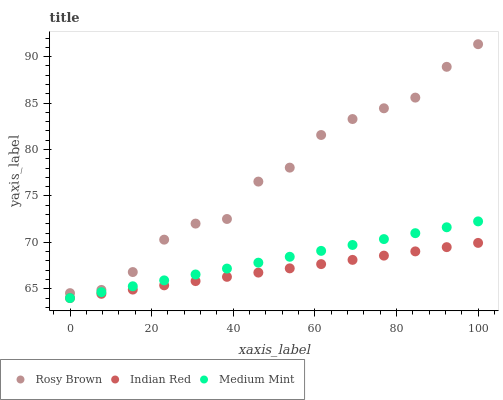Does Indian Red have the minimum area under the curve?
Answer yes or no. Yes. Does Rosy Brown have the maximum area under the curve?
Answer yes or no. Yes. Does Rosy Brown have the minimum area under the curve?
Answer yes or no. No. Does Indian Red have the maximum area under the curve?
Answer yes or no. No. Is Medium Mint the smoothest?
Answer yes or no. Yes. Is Rosy Brown the roughest?
Answer yes or no. Yes. Is Indian Red the smoothest?
Answer yes or no. No. Is Indian Red the roughest?
Answer yes or no. No. Does Medium Mint have the lowest value?
Answer yes or no. Yes. Does Rosy Brown have the lowest value?
Answer yes or no. No. Does Rosy Brown have the highest value?
Answer yes or no. Yes. Does Indian Red have the highest value?
Answer yes or no. No. Is Indian Red less than Rosy Brown?
Answer yes or no. Yes. Is Rosy Brown greater than Indian Red?
Answer yes or no. Yes. Does Indian Red intersect Medium Mint?
Answer yes or no. Yes. Is Indian Red less than Medium Mint?
Answer yes or no. No. Is Indian Red greater than Medium Mint?
Answer yes or no. No. Does Indian Red intersect Rosy Brown?
Answer yes or no. No. 